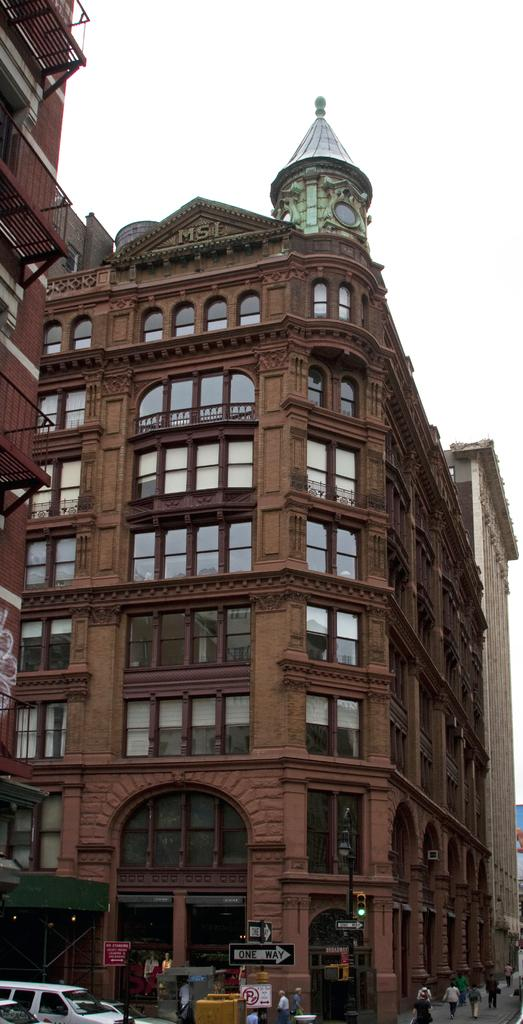What type of structures can be seen in the image? There are buildings in the image. What else is present in the image besides buildings? There are vehicles, people, boards with text, and other objects on the ground visible in the image. Can you describe the vehicles in the image? The specific types of vehicles are not mentioned, but they are present in the image. What is visible in the background of the image? The sky is visible in the background of the image. What type of tools does the carpenter use in the image? There is no carpenter present in the image, so it is not possible to answer that question. 